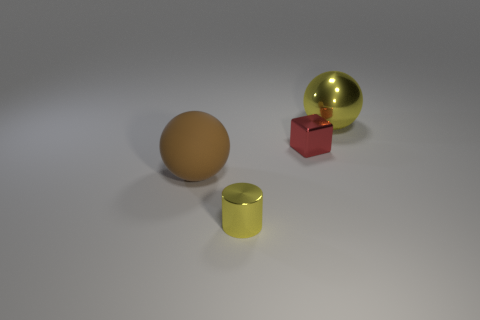The cylinder that is the same color as the shiny sphere is what size?
Your answer should be very brief. Small. What color is the shiny object that is both in front of the big yellow metal sphere and right of the tiny yellow cylinder?
Ensure brevity in your answer.  Red. The yellow object on the left side of the large object that is behind the tiny red block is made of what material?
Give a very brief answer. Metal. Does the brown matte thing have the same size as the red block?
Make the answer very short. No. How many tiny objects are either rubber objects or metallic balls?
Keep it short and to the point. 0. There is a large matte object; what number of blocks are behind it?
Make the answer very short. 1. Are there more yellow metallic objects that are to the left of the big yellow metallic ball than tiny cyan cubes?
Provide a succinct answer. Yes. There is a large thing that is the same material as the tiny yellow cylinder; what shape is it?
Provide a short and direct response. Sphere. There is a big thing that is to the left of the tiny object that is to the right of the yellow cylinder; what is its color?
Provide a succinct answer. Brown. Does the big brown rubber object have the same shape as the tiny yellow metal thing?
Your answer should be compact. No. 